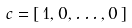Convert formula to latex. <formula><loc_0><loc_0><loc_500><loc_500>c = [ \, 1 , 0 , \dots , 0 \, ]</formula> 